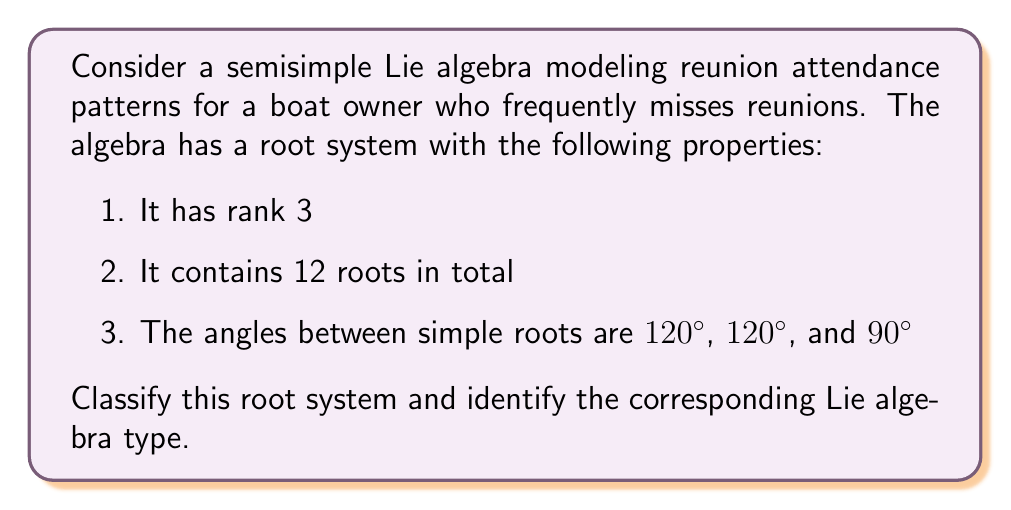Give your solution to this math problem. To classify the root system and identify the corresponding Lie algebra type, we need to analyze the given information and compare it with known root systems of semisimple Lie algebras.

1. Rank 3: This indicates that the root system is in a 3-dimensional space.

2. 12 roots in total: This is an important characteristic that will help narrow down the possibilities.

3. Angles between simple roots: 120°, 120°, and 90°

Let's consider the possible rank 3 root systems:

a) $A_3$: Has 12 roots, but all angles between simple roots are 120°
b) $B_3$: Has 18 roots
c) $C_3$: Has 18 roots
d) $D_3$: Isomorphic to $A_3$

The only rank 3 root system that matches the given properties is $A_2 \times A_1$. Here's why:

1. $A_2$ has rank 2 and 6 roots. The angle between its two simple roots is 120°.
2. $A_1$ has rank 1 and 2 roots.
3. Combining $A_2$ and $A_1$, we get:
   - Rank: 2 + 1 = 3
   - Total roots: 6 + 2 = 8
   - Angles: Two 120° angles from $A_2$, and one 90° angle between $A_2$ and $A_1$

The root system can be visualized as follows:

[asy]
import geometry;

size(200);
draw((-1,-1)--(1,1), arrow=Arrow(TeXHead));
draw((-1,1)--(1,-1), arrow=Arrow(TeXHead));
draw((0,-1.5)--(0,1.5), arrow=Arrow(TeXHead));

dot((1,0)); dot((-1,0)); dot((0.5,sqrt(3)/2)); dot((-0.5,-sqrt(3)/2));
dot((0.5,-sqrt(3)/2)); dot((-0.5,sqrt(3)/2));
dot((0,1)); dot((0,-1));

label("$A_2$", (1.2,1.2));
label("$A_1$", (0.2,1.5));
[/asy]

The corresponding Lie algebra type for $A_2 \times A_1$ is $\mathfrak{su}(3) \times \mathfrak{su}(2)$ or $\mathfrak{sl}(3, \mathbb{C}) \times \mathfrak{sl}(2, \mathbb{C})$.

This root system can model reunion attendance patterns where there are three main factors influencing attendance (rank 3), with two factors being closely related (A_2 component) and one factor being independent (A_1 component). The 12 roots represent different combinations of these factors affecting attendance decisions.
Answer: The root system is classified as $A_2 \times A_1$, corresponding to the Lie algebra type $\mathfrak{su}(3) \times \mathfrak{su}(2)$ or $\mathfrak{sl}(3, \mathbb{C}) \times \mathfrak{sl}(2, \mathbb{C})$. 